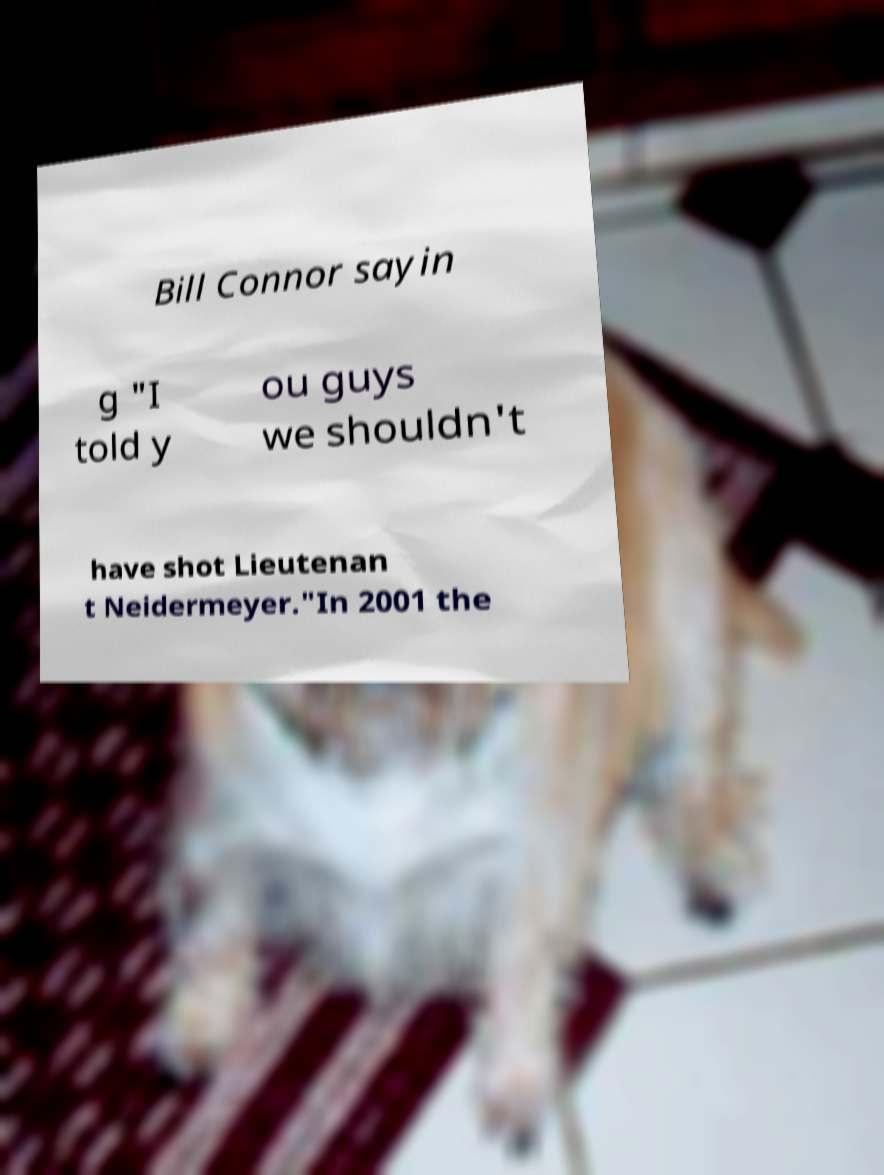Could you assist in decoding the text presented in this image and type it out clearly? Bill Connor sayin g "I told y ou guys we shouldn't have shot Lieutenan t Neidermeyer."In 2001 the 